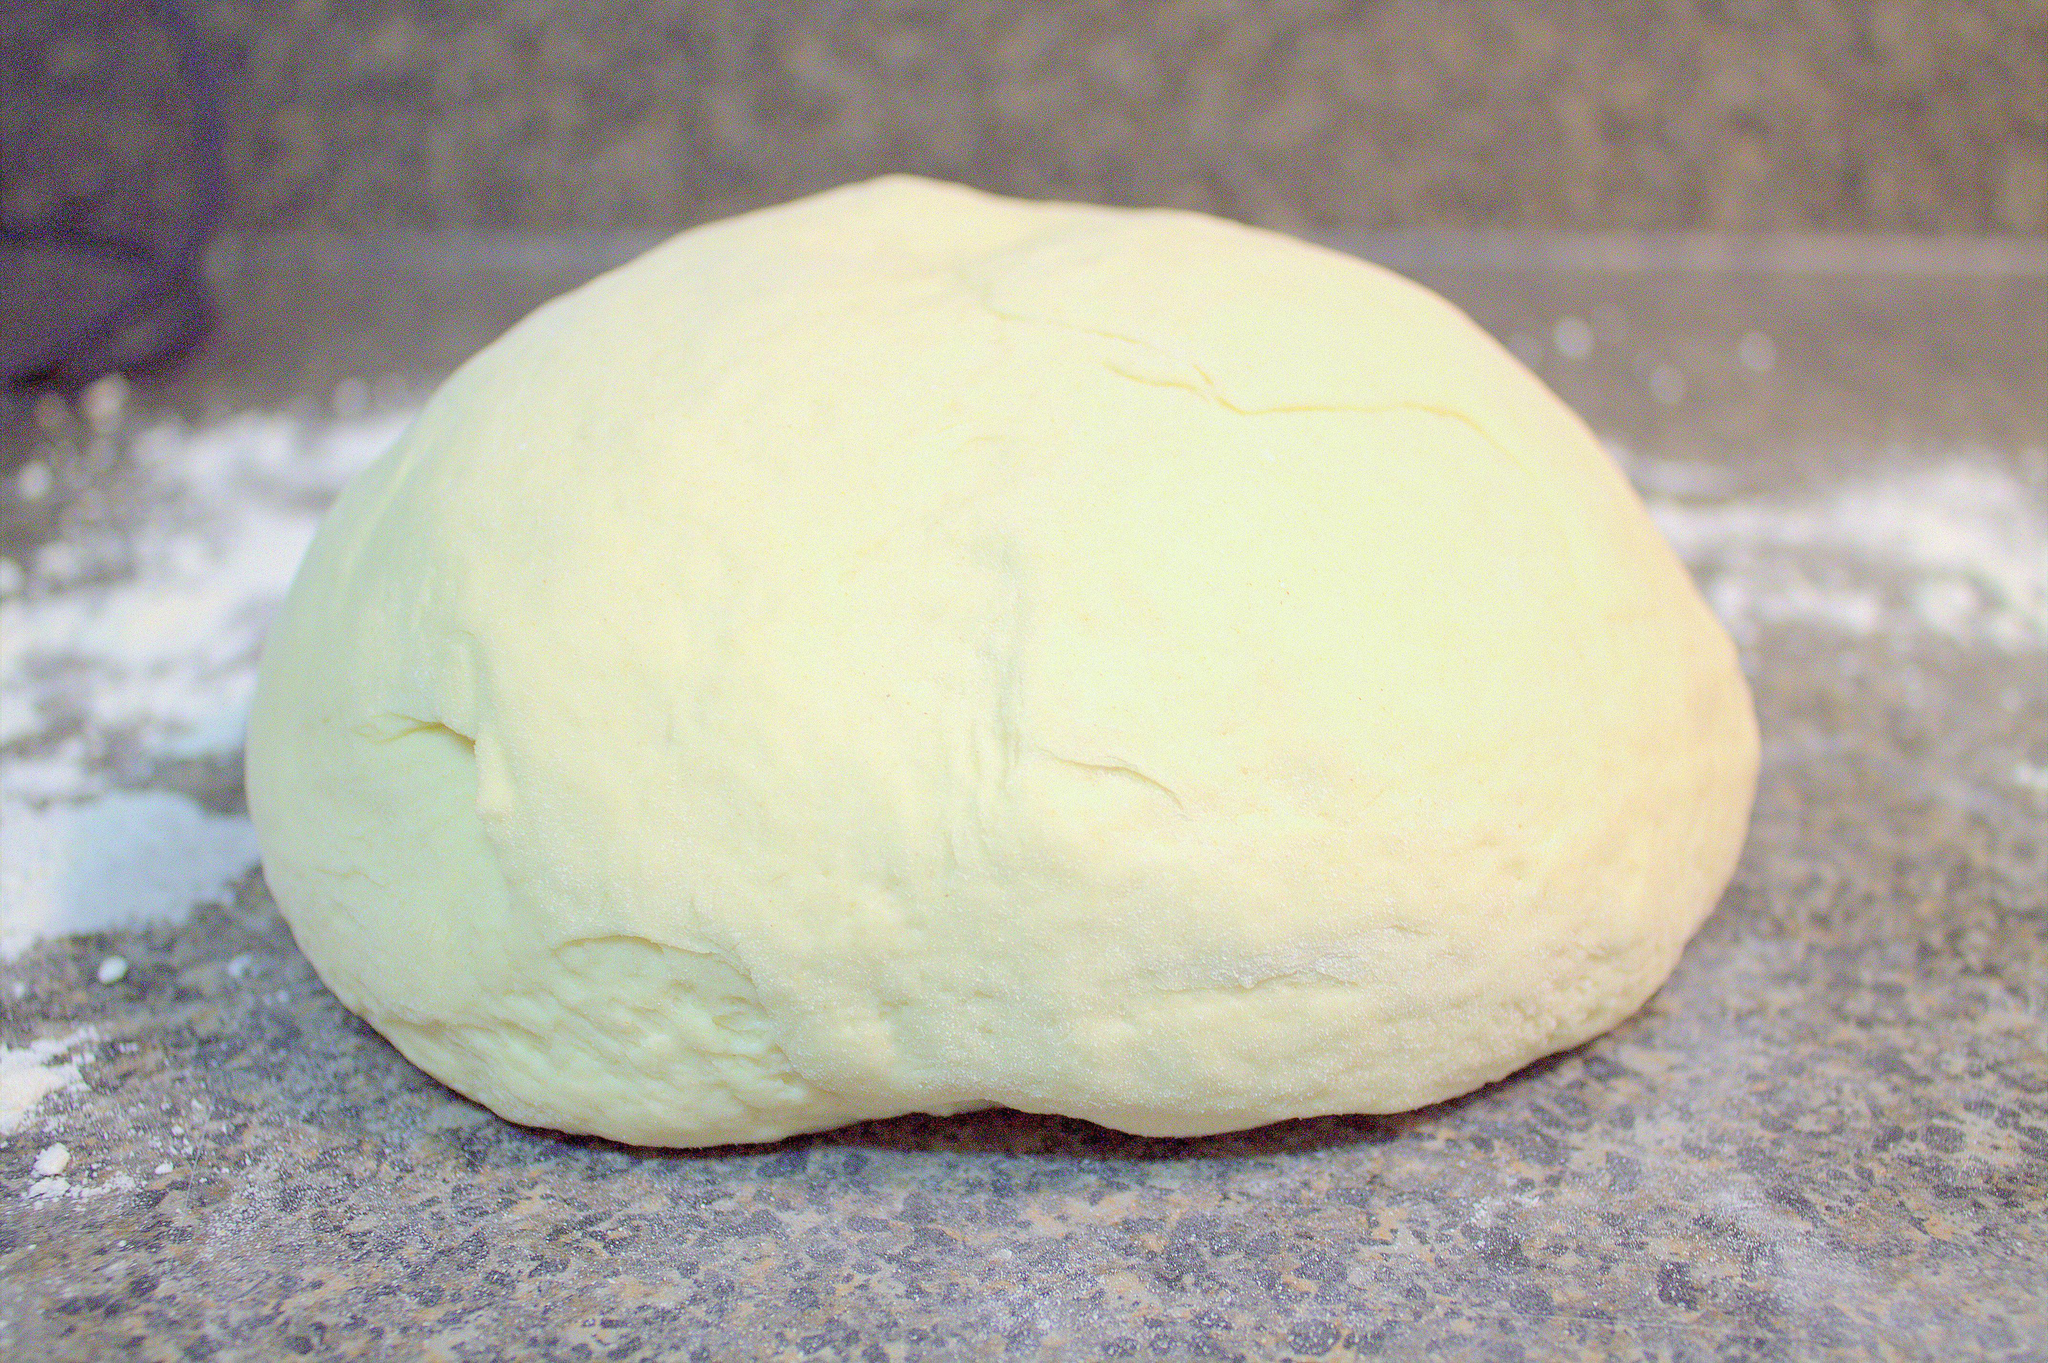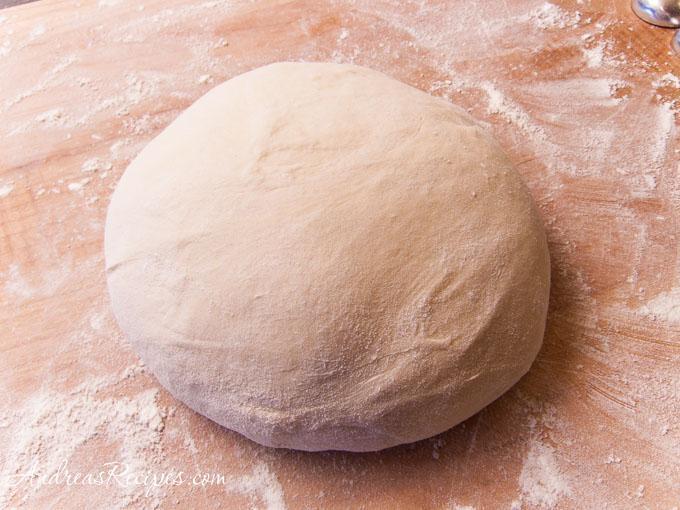The first image is the image on the left, the second image is the image on the right. Assess this claim about the two images: "The left and right image contains the same number of balls of dough.". Correct or not? Answer yes or no. Yes. The first image is the image on the left, the second image is the image on the right. For the images displayed, is the sentence "Each image contains one rounded ball of raw dough." factually correct? Answer yes or no. Yes. 